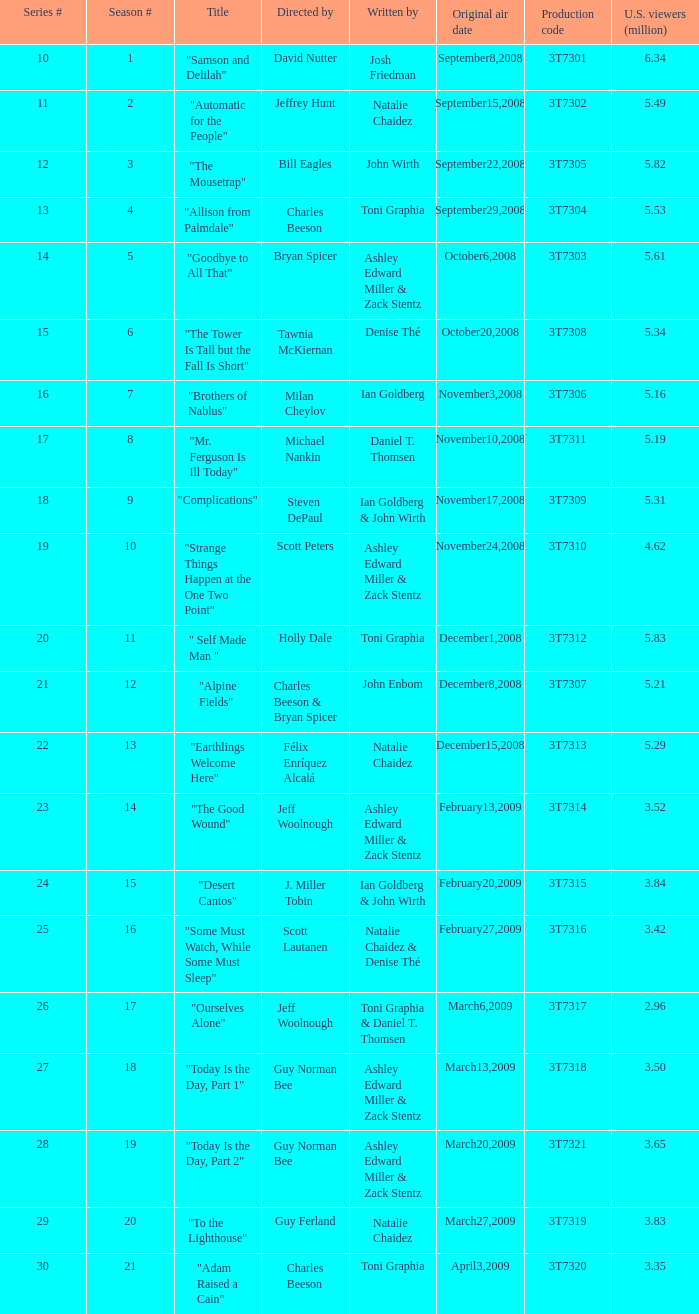Which episode number was directed by Bill Eagles? 12.0. 